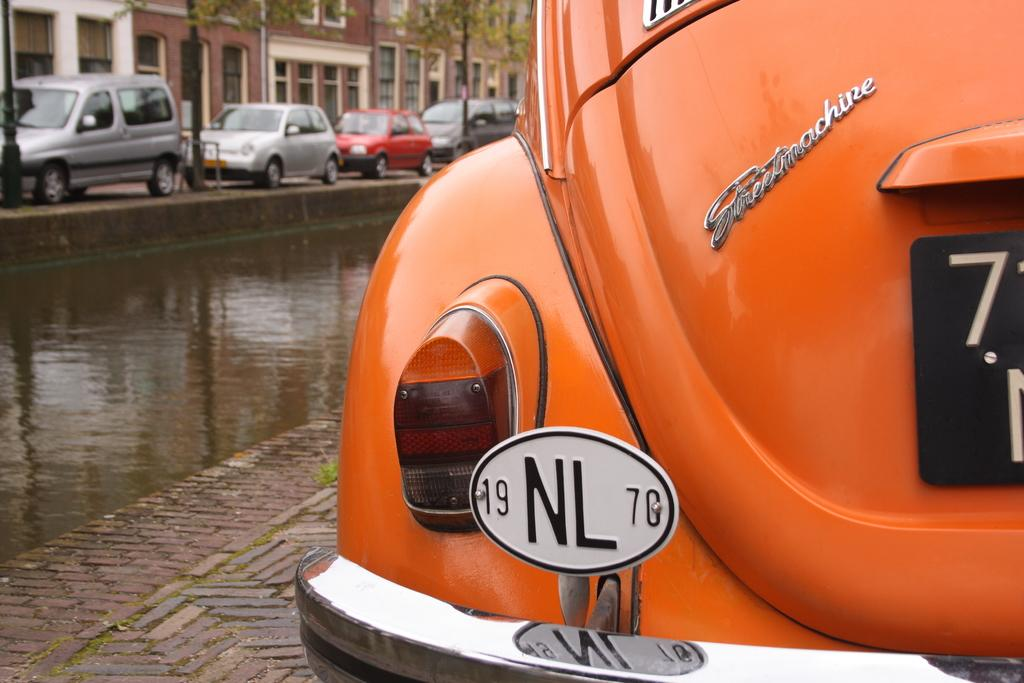What type of view is shown in the image? The image is an outside view. What can be seen on the road in the image? There are cars on the road in the image. What is visible in the background of the image? There are buildings and trees in the background of the image. What effect do the brothers have on the government in the image? There is no mention of brothers or the government in the image, so it is not possible to answer that question. 